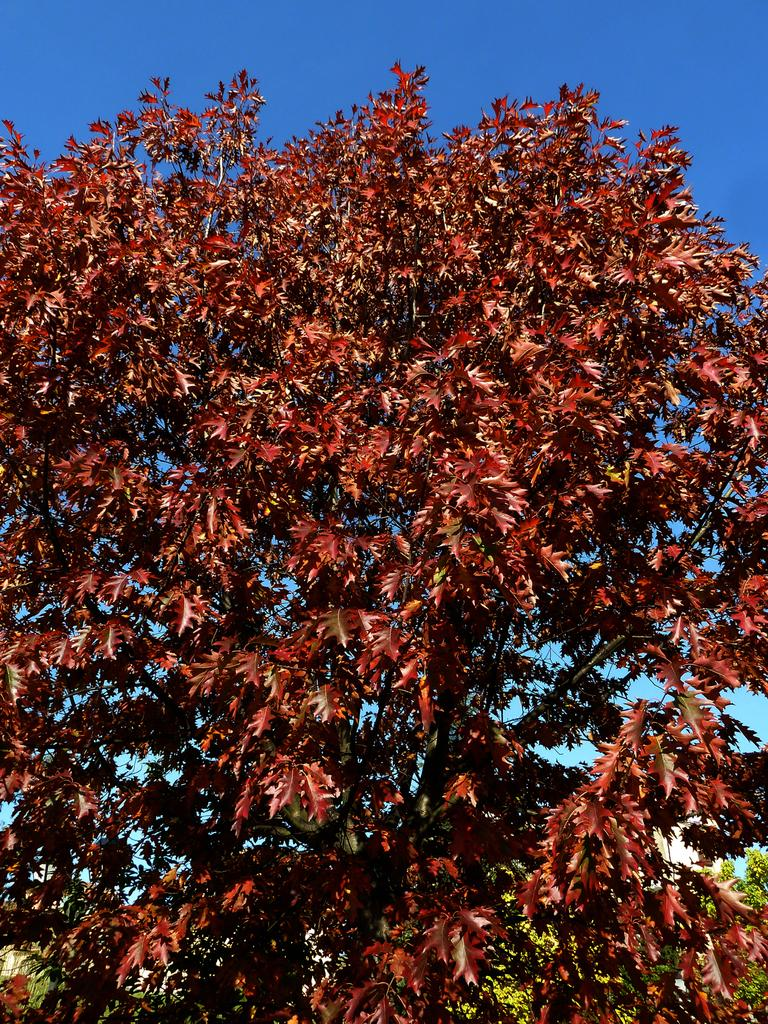What is the main subject in the image? There is a tree in the image. What is unique about the tree's appearance? The tree has orange leaves. What can be seen in the background of the image? The sky is visible in the background of the image. What type of class is being held under the tree in the image? There is no class or any indication of a class being held in the image. What is the air quality like in the image? There is no information about the air quality in the image. 